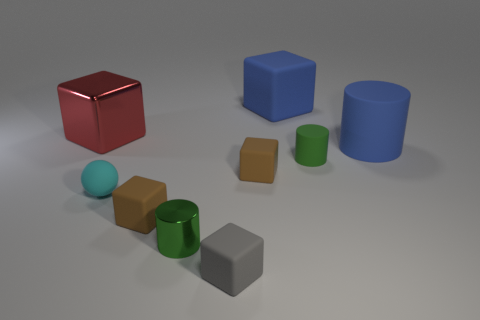What size is the block that is the same color as the large cylinder?
Offer a very short reply. Large. What color is the rubber sphere that is the same size as the green metal object?
Keep it short and to the point. Cyan. What number of things are both to the left of the big rubber block and in front of the blue matte cylinder?
Your response must be concise. 5. What material is the big blue block?
Your answer should be compact. Rubber. What number of things are gray blocks or large cyan matte cylinders?
Give a very brief answer. 1. Is the size of the block to the left of the small cyan object the same as the blue block that is to the right of the tiny matte ball?
Ensure brevity in your answer.  Yes. How many other things are the same size as the blue cube?
Provide a short and direct response. 2. What number of things are large blue matte things in front of the large blue matte cube or green cylinders behind the green shiny cylinder?
Provide a short and direct response. 2. Is the large red object made of the same material as the small block behind the tiny cyan ball?
Your answer should be very brief. No. How many other things are there of the same shape as the green metal thing?
Your response must be concise. 2. 